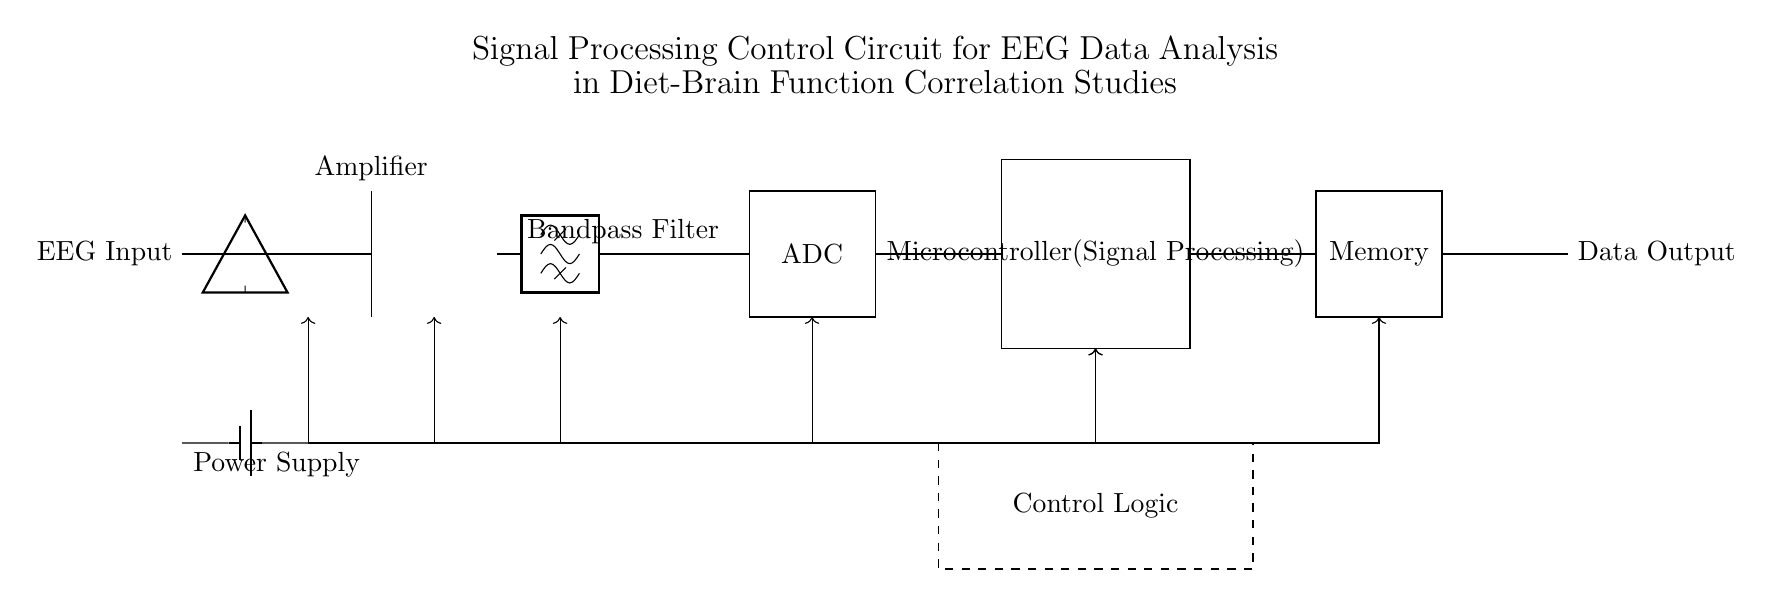What is the input type for this circuit? The input type is EEG Input, as labeled in the circuit diagram indicating the source of the electrical signals being analyzed.
Answer: EEG Input What component is responsible for amplifying the signal? The component responsible for amplifying the signal is the Amplifier, which is represented in the diagram and central to boosting the EEG signal strength for further processing.
Answer: Amplifier What type of filter is used in this circuit? The circuit uses a Bandpass Filter, which is indicated in the diagram and is typically employed to allow certain frequency ranges while blocking others, essential for EEG signal processing.
Answer: Bandpass Filter Which component converts the analog signal to a digital signal? The ADC (Analog to Digital Converter) converts the analog signal into a digital signal, as shown in the rectangle labeled ADC in the circuit.
Answer: ADC How many main processing components are present in the circuit? There are three main processing components: the Amplifier, the ADC, and the Microcontroller, which work together to process the EEG data.
Answer: Three What is the purpose of the Control Logic in this circuit? The Control Logic provides the necessary commands and manages the operation of the processing components, ensuring that the signals are being handled correctly; it is an analytical aspect of the control system visible beneath the Microcontroller.
Answer: Control Logic What is the function of the Memory component? The Memory component stores the processed EEG data, allowing for later retrieval and analysis, indicated in the rectangle labeled Memory.
Answer: Memory 